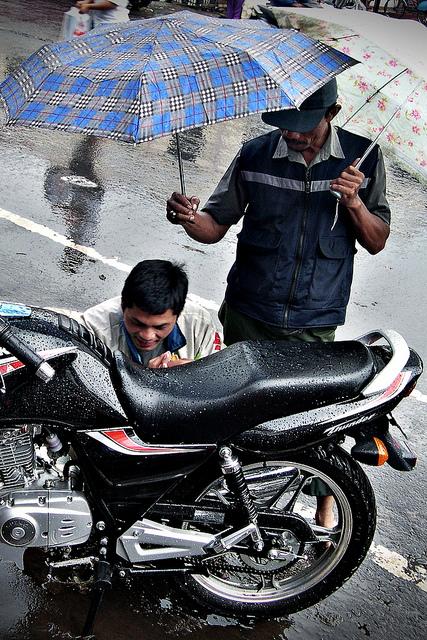Does the vehicle have a chain?
Give a very brief answer. Yes. What color is the umbrella?
Be succinct. Blue. Is this man helping someone fix a bike?
Write a very short answer. Yes. 